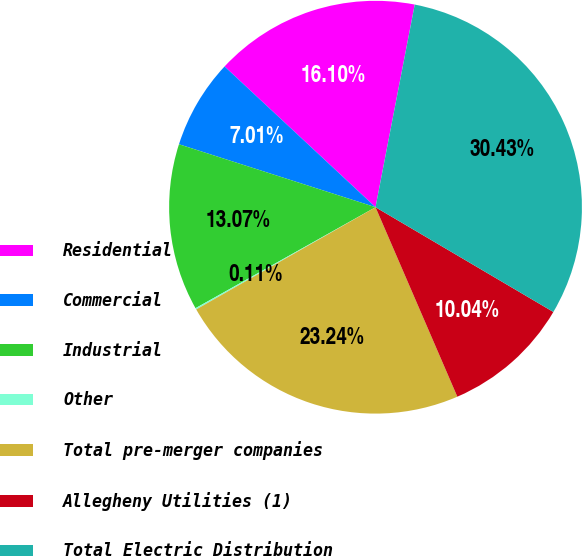Convert chart to OTSL. <chart><loc_0><loc_0><loc_500><loc_500><pie_chart><fcel>Residential<fcel>Commercial<fcel>Industrial<fcel>Other<fcel>Total pre-merger companies<fcel>Allegheny Utilities (1)<fcel>Total Electric Distribution<nl><fcel>16.1%<fcel>7.01%<fcel>13.07%<fcel>0.11%<fcel>23.24%<fcel>10.04%<fcel>30.43%<nl></chart> 